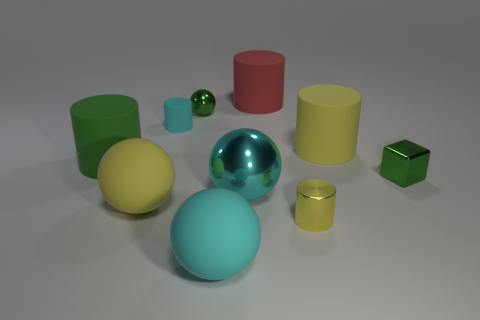What number of other metallic spheres have the same size as the green shiny sphere?
Make the answer very short. 0. Is the number of green blocks in front of the red cylinder less than the number of shiny objects that are in front of the big metal thing?
Offer a terse response. No. Are there any other tiny shiny objects of the same shape as the tiny cyan thing?
Make the answer very short. Yes. Is the big red rubber object the same shape as the big cyan metallic object?
Give a very brief answer. No. How many big things are shiny blocks or cyan things?
Offer a terse response. 2. Are there more shiny balls than green spheres?
Give a very brief answer. Yes. The red thing that is made of the same material as the tiny cyan thing is what size?
Make the answer very short. Large. There is a cylinder that is in front of the small block; is its size the same as the shiny ball that is to the right of the green metallic ball?
Provide a short and direct response. No. How many objects are either cyan metal spheres on the right side of the green cylinder or cyan metallic spheres?
Your response must be concise. 1. Is the number of red objects less than the number of big purple metal cylinders?
Your answer should be compact. No. 